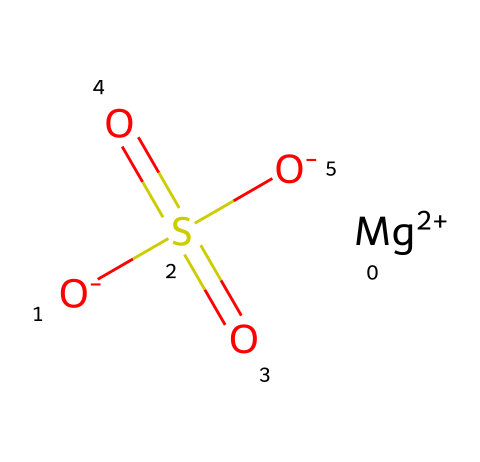What is the total number of atoms in magnesium sulfate? The chemical representation contains one magnesium atom, one sulfur atom, and four oxygen atoms (two from the sulfate group and two resulting from the negative charges), leading to a total of six atoms.
Answer: six How many sulfate groups are present in magnesium sulfate? The structure shows sulfate ions denoted by "S(=O)(=O)[O-]", indicating there is one sulfate group attached to magnesium.
Answer: one What charge does the magnesium ion have in this compound? Observing the "Mg+2" indicates that the magnesium ion carries a +2 charge, consistent with its typical oxidation state.
Answer: +2 What is the name of the compound with the chemical structure provided? The chemical formula corresponds to magnesium sulfate, commonly known as Epsom salt.
Answer: magnesium sulfate How does magnesium sulfate function as an electrolyte in solutions? In a solution, magnesium sulfate dissociates into its components: magnesium ions and sulfate ions, allowing the conduction of electricity, which defines its role as an electrolyte.
Answer: conducts electricity What is the oxidation state of sulfur in magnesium sulfate? In the structure, sulfur is double-bonded to two oxygen atoms and singly bonded to one oxygen with a negative charge, leading to an oxidation state of +6 for sulfur in sulfate.
Answer: +6 How many oxygen atoms are bonded to sulfur in this compound? The representation indicates that sulfur is connected to four oxygen atoms in total (two are double-bonded, and two are single-bonded with negative charges).
Answer: four 